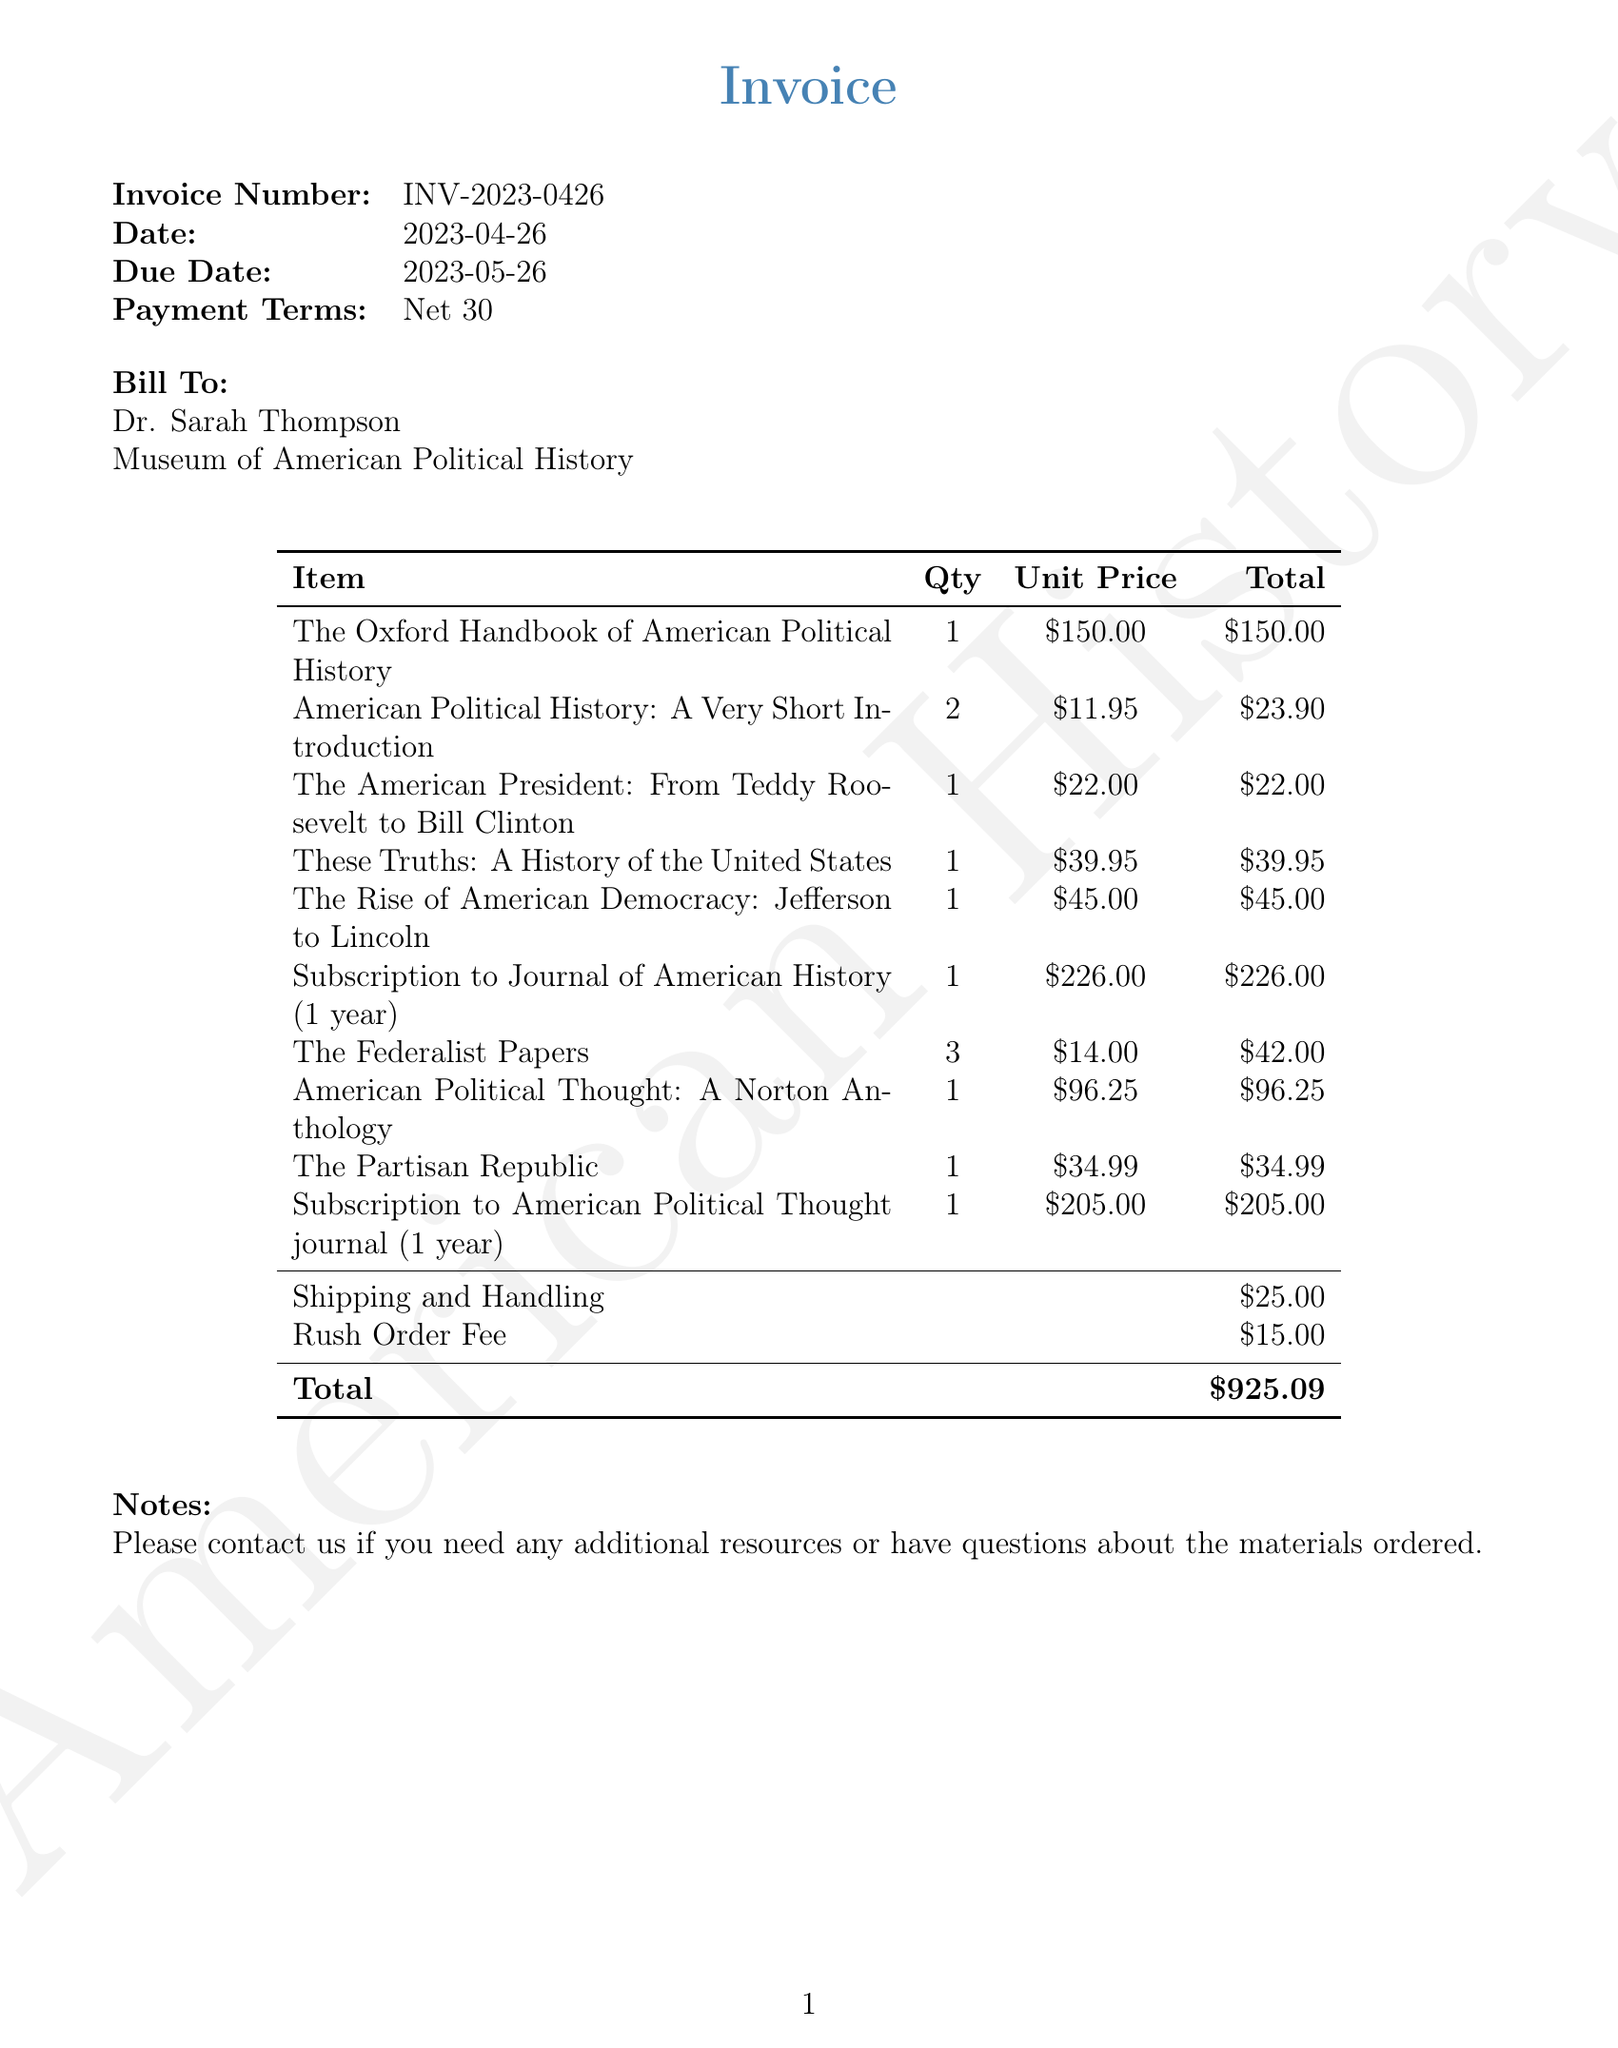What is the invoice number? The invoice number is specifically mentioned in the document as a unique identifier for the transaction.
Answer: INV-2023-0426 What is the payment term for this invoice? The payment terms indicate the timeframe within which the payment should be made, stated clearly in the document.
Answer: Net 30 How many copies of "American Political History: A Very Short Introduction" were ordered? This information is found in the itemized list of books, showing the quantity of each title ordered.
Answer: 2 Who is the publisher of "The Federalist Papers"? The publisher's name is included next to each book title in the list, providing essential bibliographic information.
Answer: Penguin Classics What is the total amount due for this invoice? The total amount is calculated from the sum of all item prices and additional charges, clearly stated at the bottom of the invoice.
Answer: $925.09 What additional charges are included in the invoice? The document lists specific extra charges, which adds to the total amount due, typically seen in invoices.
Answer: Shipping and Handling, Rush Order Fee Which item has the highest unit price? By examining the unit prices listed, we can determine which item costs the most individually.
Answer: Subscription to Journal of American History (1 year) What date is the invoice due? The due date is clearly specified in the document, indicating when payment is expected.
Answer: 2023-05-26 What is the name of the person to whom the invoice is billed? The billing name is mentioned at the beginning of the invoice, providing clarity on who is responsible for payment.
Answer: Dr. Sarah Thompson 